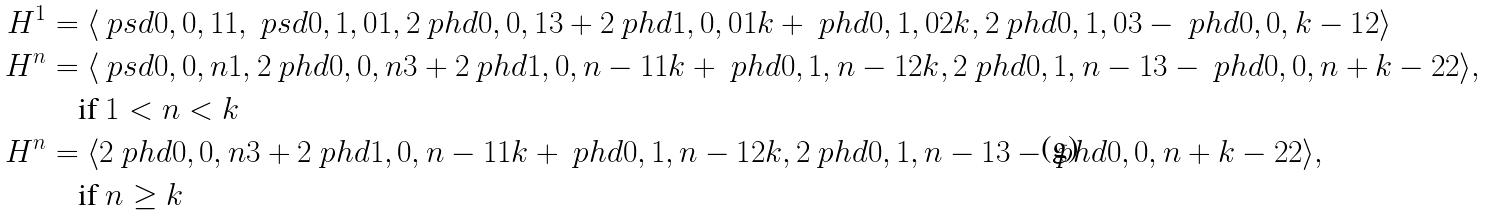<formula> <loc_0><loc_0><loc_500><loc_500>H ^ { 1 } & = \langle \ p s d { 0 , 0 , 1 } 1 , \ p s d { 0 , 1 , 0 } 1 , 2 \ p h d { 0 , 0 , 1 } 3 + 2 \ p h d { 1 , 0 , 0 } 1 k + \ p h d { 0 , 1 , 0 } 2 k , 2 \ p h d { 0 , 1 , 0 } 3 - \ p h d { 0 , 0 , k - 1 } 2 \rangle \\ H ^ { n } & = \langle \ p s d { 0 , 0 , n } 1 , 2 \ p h d { 0 , 0 , n } 3 + 2 \ p h d { 1 , 0 , n - 1 } 1 k + \ p h d { 0 , 1 , n - 1 } 2 k , 2 \ p h d { 0 , 1 , n - 1 } 3 - \ p h d { 0 , 0 , n + k - 2 } 2 \rangle , \\ & \quad \text {if $1<n<k$} \\ H ^ { n } & = \langle 2 \ p h d { 0 , 0 , n } 3 + 2 \ p h d { 1 , 0 , n - 1 } 1 k + \ p h d { 0 , 1 , n - 1 } 2 k , 2 \ p h d { 0 , 1 , n - 1 } 3 - \ p h d { 0 , 0 , n + k - 2 } 2 \rangle , \\ & \quad \text {if $n\geq k$}</formula> 